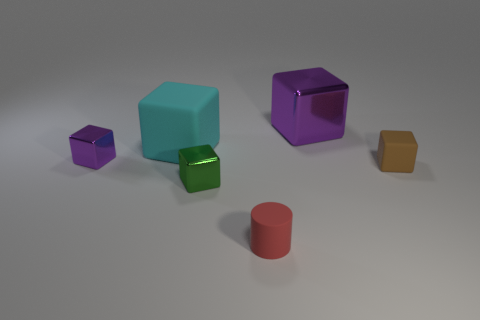Subtract all purple metal cubes. How many cubes are left? 3 Subtract 2 purple blocks. How many objects are left? 4 Subtract all cylinders. How many objects are left? 5 Subtract 4 blocks. How many blocks are left? 1 Subtract all green cylinders. Subtract all yellow spheres. How many cylinders are left? 1 Subtract all gray cylinders. How many green cubes are left? 1 Subtract all brown objects. Subtract all small red cylinders. How many objects are left? 4 Add 6 small brown matte cubes. How many small brown matte cubes are left? 7 Add 6 brown metal spheres. How many brown metal spheres exist? 6 Add 4 cyan blocks. How many objects exist? 10 